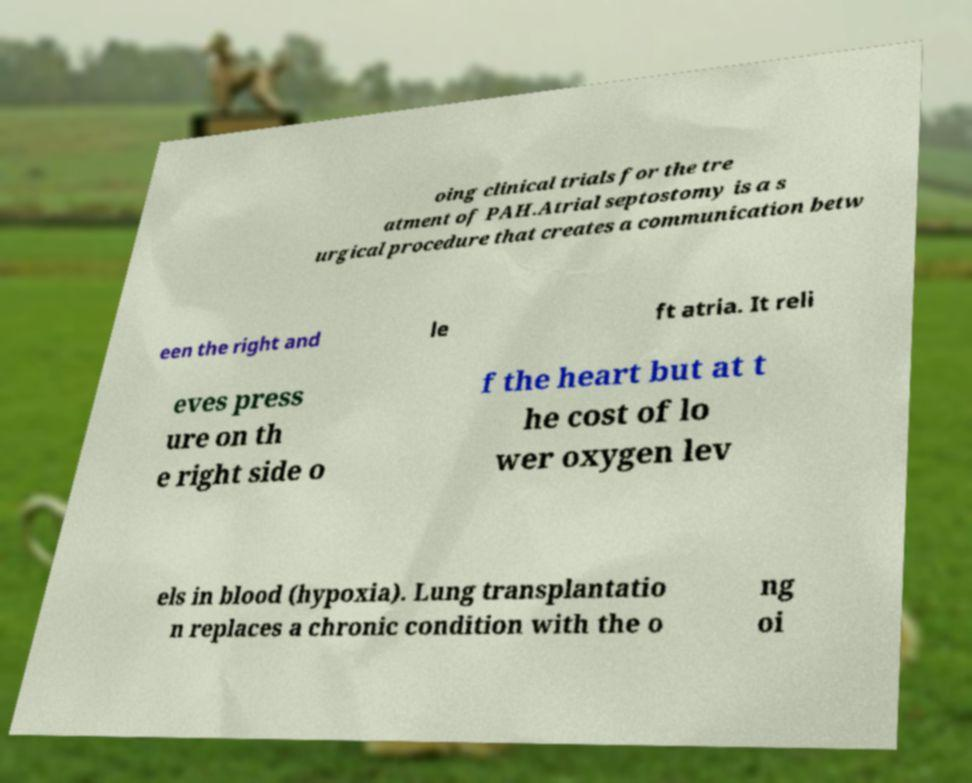Please identify and transcribe the text found in this image. oing clinical trials for the tre atment of PAH.Atrial septostomy is a s urgical procedure that creates a communication betw een the right and le ft atria. It reli eves press ure on th e right side o f the heart but at t he cost of lo wer oxygen lev els in blood (hypoxia). Lung transplantatio n replaces a chronic condition with the o ng oi 